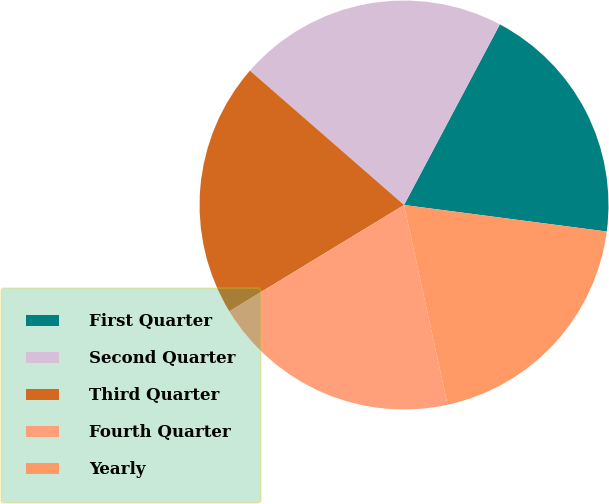Convert chart to OTSL. <chart><loc_0><loc_0><loc_500><loc_500><pie_chart><fcel>First Quarter<fcel>Second Quarter<fcel>Third Quarter<fcel>Fourth Quarter<fcel>Yearly<nl><fcel>19.31%<fcel>21.35%<fcel>20.11%<fcel>19.72%<fcel>19.51%<nl></chart> 